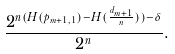<formula> <loc_0><loc_0><loc_500><loc_500>\frac { 2 ^ { n ( H ( p _ { m + 1 , 1 } ) - H ( \frac { d _ { m + 1 } } { n } ) ) - \delta } } { 2 ^ { n } } .</formula> 